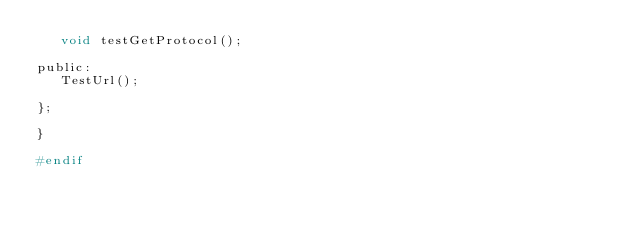<code> <loc_0><loc_0><loc_500><loc_500><_C_>   void testGetProtocol();

public:
   TestUrl();

};
   
}

#endif

</code> 